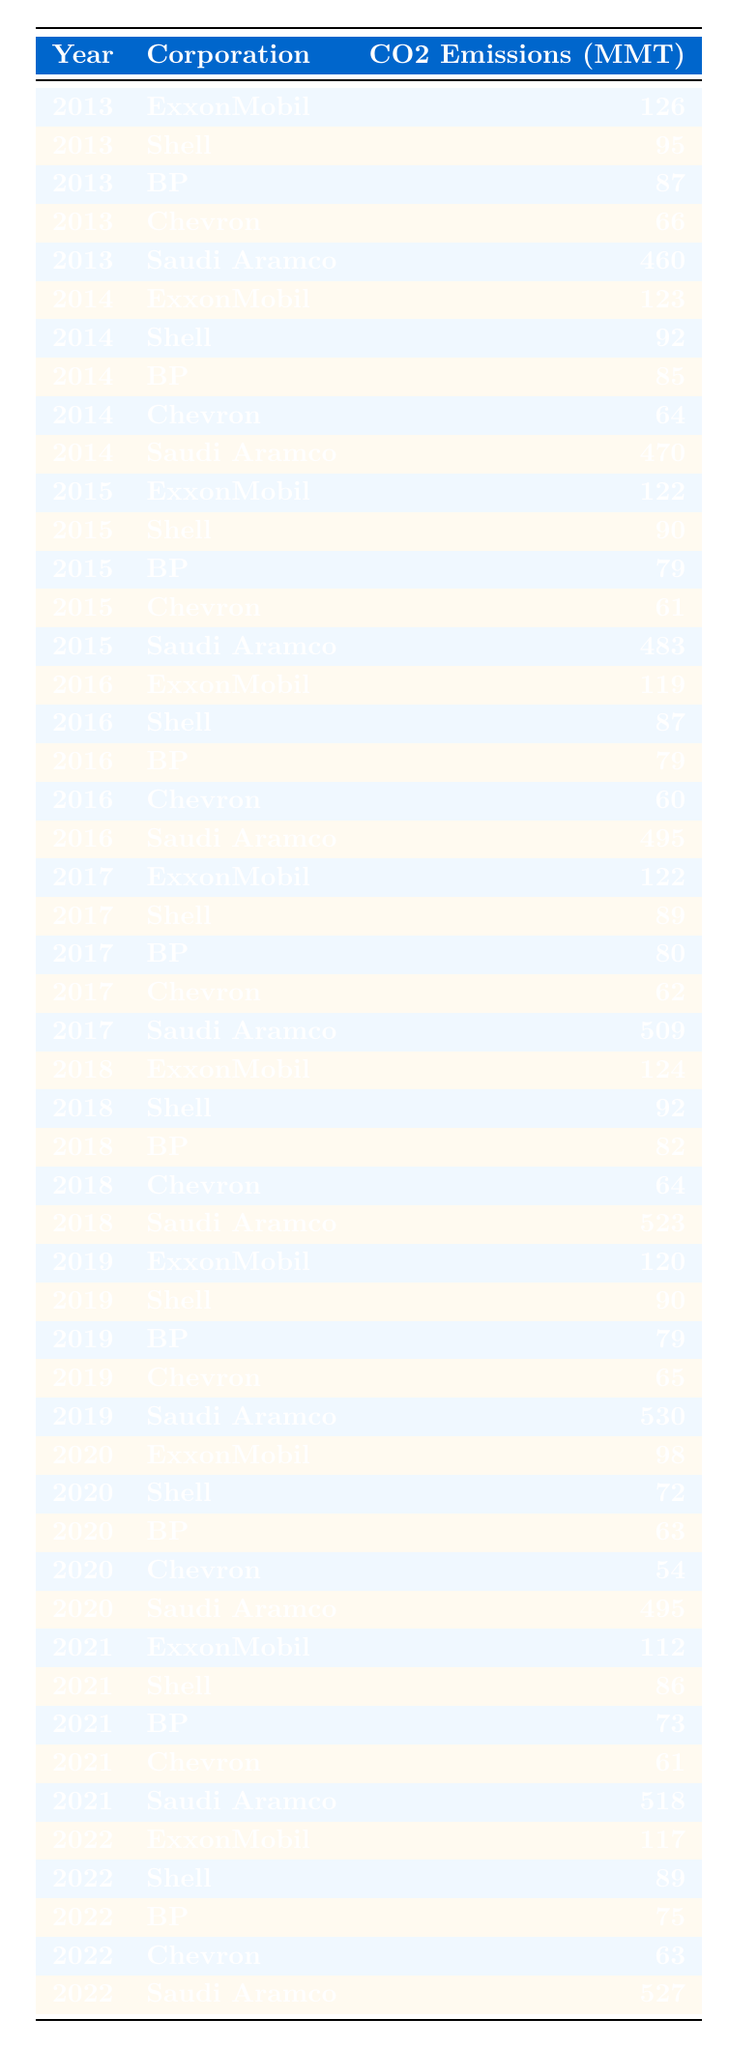What was the CO2 emissions of Saudi Aramco in 2020? In the table, under the year 2020, the entry for Saudi Aramco shows CO2 emissions of 495 million metric tons.
Answer: 495 million metric tons Which corporation had the highest CO2 emissions in 2019? Looking at the data for 2019, Saudi Aramco had the highest CO2 emissions recorded at 530 million metric tons, higher than any other corporation in that year.
Answer: Saudi Aramco What is the difference in CO2 emissions from 2013 to 2022 for BP? For BP, the emissions in 2013 were 87 million metric tons, and in 2022 they were 75 million metric tons. The difference is 87 - 75 = 12 million metric tons.
Answer: 12 million metric tons What is the average CO2 emissions for Chevron over the decade? Summing the emissions from Chevron over each year: 66, 64, 61, 60, 62, 64, 65, 54, 61, and 63 gives a total of 610 million metric tons. Dividing this by 10 (the number of years) gives an average of 61 million metric tons.
Answer: 61 million metric tons Did ExxonMobil's CO2 emissions increase in the year 2017 compared to 2016? In 2016, ExxonMobil's emissions were 119 million metric tons, while in 2017, they were 122 million metric tons. Since 122 is greater than 119, this indicates an increase.
Answer: Yes Which corporation consistently had the lowest CO2 emissions throughout the decade? Evaluating each corporation’s emissions, Chevron had the lowest maximum emissions for every year compared to the others, with the highest in a given year being 66 million metric tons in 2013, thus it was consistently lower than others.
Answer: Chevron What was the trend for Shell's CO2 emissions from 2013 to 2022? By examining Shell's annual emissions: 95, 92, 90, 87, 89, 92, 90, 72, 86, and 89, the data shows fluctuations but an overall decline in the emissions from 2013 until 2020 before rising slightly in the last two years.
Answer: Fluctuating decline with slight increase in last two years How much did CO2 emissions for Saudi Aramco increase from 2013 to 2018? Saudi Aramco's emissions were 460 million metric tons in 2013 and 523 million metric tons in 2018. The increase is calculated by subtracting 460 from 523, giving an increase of 63 million metric tons.
Answer: 63 million metric tons Which year saw the lowest CO2 emissions for ExxonMobil? In the table, the lowest recorded emissions for ExxonMobil occurred in 2020 when their emissions were 98 million metric tons.
Answer: 2020 What was the total CO2 emissions for all corporations in 2021? By adding the emissions from all corporations in 2021: 112 (ExxonMobil) + 86 (Shell) + 73 (BP) + 61 (Chevron) + 518 (Saudi Aramco) gives a cumulative total of 850 million metric tons.
Answer: 850 million metric tons 